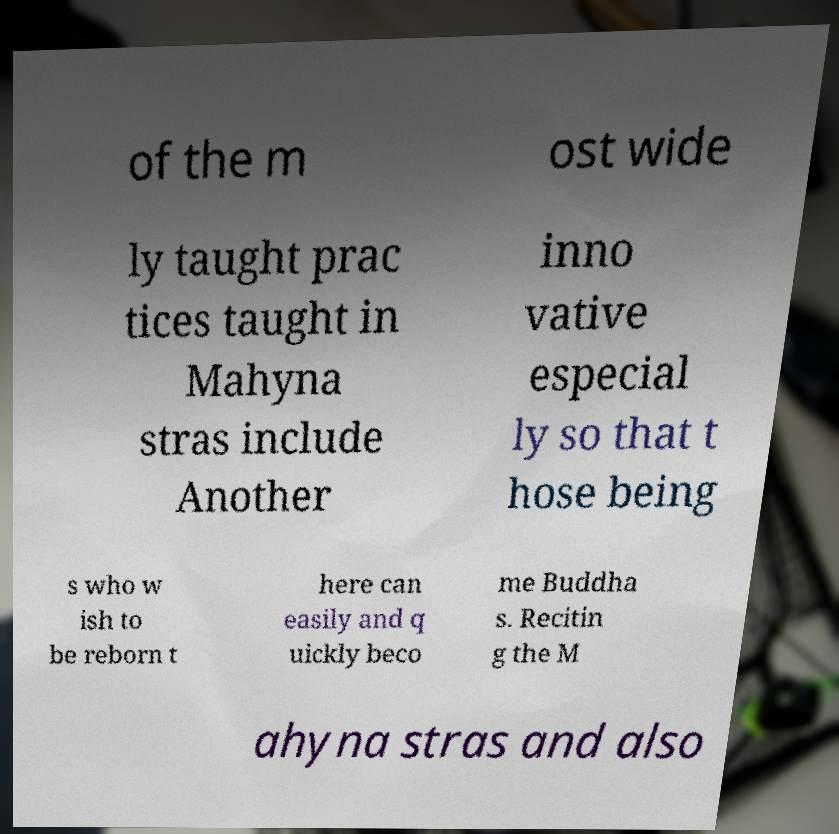Can you read and provide the text displayed in the image?This photo seems to have some interesting text. Can you extract and type it out for me? of the m ost wide ly taught prac tices taught in Mahyna stras include Another inno vative especial ly so that t hose being s who w ish to be reborn t here can easily and q uickly beco me Buddha s. Recitin g the M ahyna stras and also 